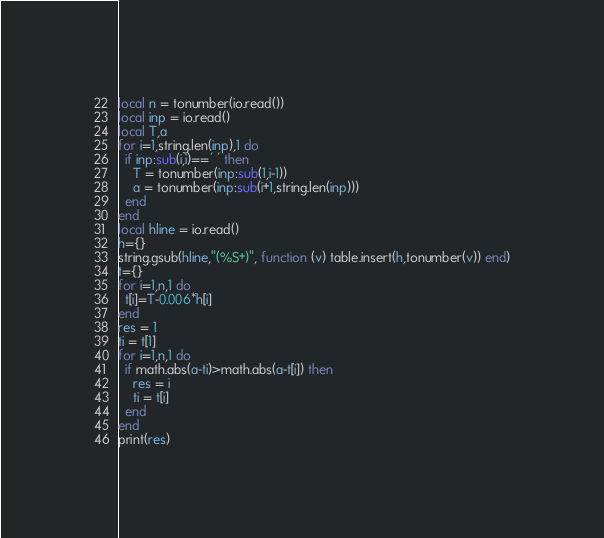<code> <loc_0><loc_0><loc_500><loc_500><_Lua_>local n = tonumber(io.read())
local inp = io.read()
local T,a
for i=1,string.len(inp),1 do
  if inp:sub(i,i)==' ' then
    T = tonumber(inp:sub(1,i-1))
    a = tonumber(inp:sub(i+1,string.len(inp)))
  end
end
local hline = io.read()
h={}
string.gsub(hline,"(%S+)", function (v) table.insert(h,tonumber(v)) end)
t={}
for i=1,n,1 do
  t[i]=T-0.006*h[i]
end
res = 1
ti = t[1]
for i=1,n,1 do
  if math.abs(a-ti)>math.abs(a-t[i]) then
    res = i
    ti = t[i]
  end
end
print(res)</code> 